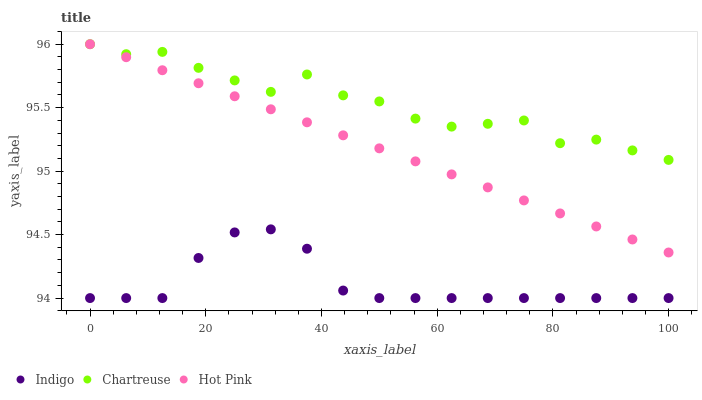Does Indigo have the minimum area under the curve?
Answer yes or no. Yes. Does Chartreuse have the maximum area under the curve?
Answer yes or no. Yes. Does Hot Pink have the minimum area under the curve?
Answer yes or no. No. Does Hot Pink have the maximum area under the curve?
Answer yes or no. No. Is Hot Pink the smoothest?
Answer yes or no. Yes. Is Chartreuse the roughest?
Answer yes or no. Yes. Is Indigo the smoothest?
Answer yes or no. No. Is Indigo the roughest?
Answer yes or no. No. Does Indigo have the lowest value?
Answer yes or no. Yes. Does Hot Pink have the lowest value?
Answer yes or no. No. Does Hot Pink have the highest value?
Answer yes or no. Yes. Does Indigo have the highest value?
Answer yes or no. No. Is Indigo less than Hot Pink?
Answer yes or no. Yes. Is Chartreuse greater than Indigo?
Answer yes or no. Yes. Does Chartreuse intersect Hot Pink?
Answer yes or no. Yes. Is Chartreuse less than Hot Pink?
Answer yes or no. No. Is Chartreuse greater than Hot Pink?
Answer yes or no. No. Does Indigo intersect Hot Pink?
Answer yes or no. No. 